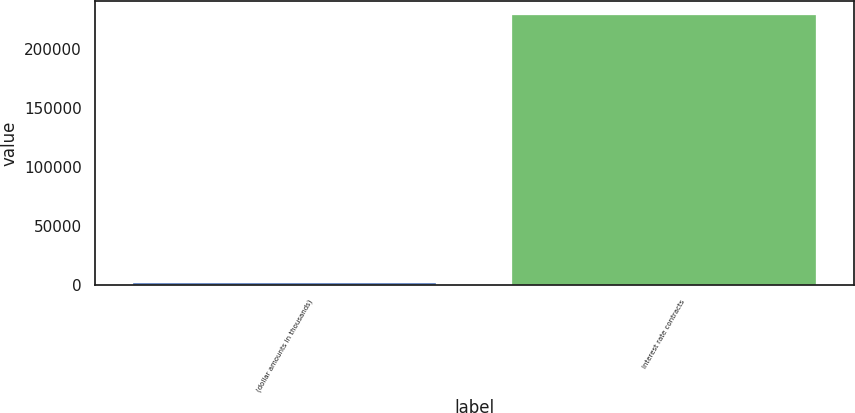<chart> <loc_0><loc_0><loc_500><loc_500><bar_chart><fcel>(dollar amounts in thousands)<fcel>Interest rate contracts<nl><fcel>2012<fcel>228757<nl></chart> 